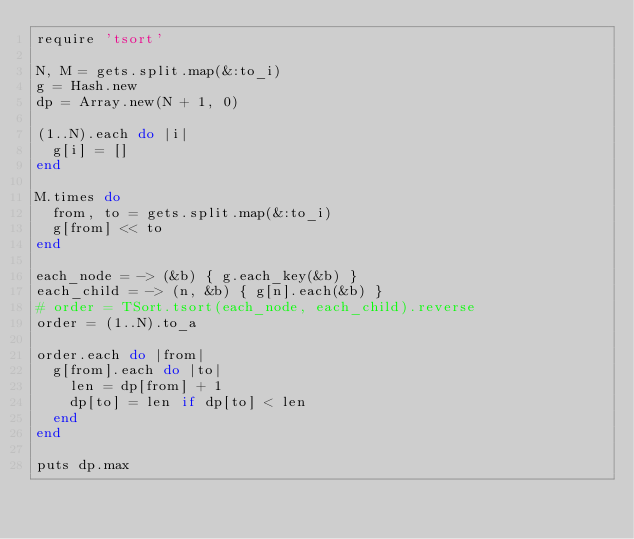<code> <loc_0><loc_0><loc_500><loc_500><_Ruby_>require 'tsort'

N, M = gets.split.map(&:to_i)
g = Hash.new
dp = Array.new(N + 1, 0)

(1..N).each do |i|
  g[i] = []
end

M.times do
  from, to = gets.split.map(&:to_i)
  g[from] << to
end

each_node = -> (&b) { g.each_key(&b) }
each_child = -> (n, &b) { g[n].each(&b) }
# order = TSort.tsort(each_node, each_child).reverse
order = (1..N).to_a

order.each do |from|
  g[from].each do |to|
    len = dp[from] + 1
    dp[to] = len if dp[to] < len
  end
end

puts dp.max
</code> 